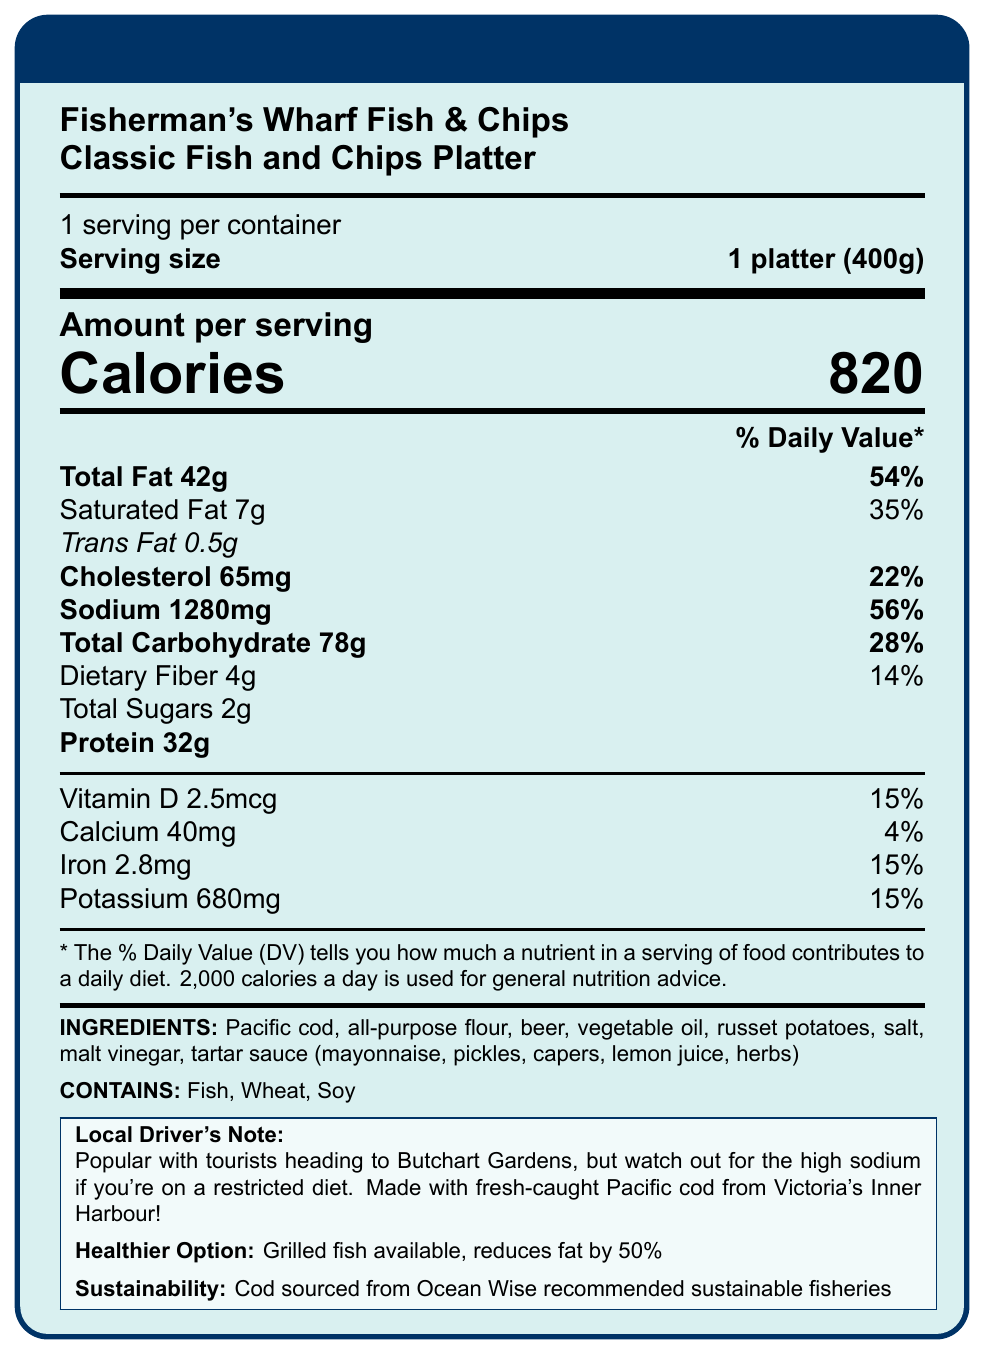what is the total fat content in the Classic Fish and Chips Platter? The document shows that the total fat content for the Classic Fish and Chips Platter is 42g.
Answer: 42g how many calories are in one serving of the Classic Fish and Chips Platter? The document states the calories per serving as 820.
Answer: 820 calories what percentage of the daily value does the sodium content of the platter represent? The document lists the sodium content as 1280mg, which is 56% of the daily value.
Answer: 56% what are the main allergens present in the Classic Fish and Chips Platter? The document clearly mentions that the platter contains Fish, Wheat, and Soy as allergens.
Answer: Fish, Wheat, Soy what is the serving size for this meal? The serving size information is listed as "1 platter (400g)" in the document.
Answer: 1 platter (400g) how much saturated fat is in the Classic Fish and Chips Platter? The document specifies that the saturated fat content is 7g.
Answer: 7g what are the ingredients used in the Classic Fish and Chips Platter? The document has a detailed list of ingredients.
Answer: Pacific cod, all-purpose flour, beer, vegetable oil, russet potatoes, salt, malt vinegar, tartar sauce (mayonnaise, pickles, capers, lemon juice, herbs) which nutrient has the highest daily value percentage in the meal? A. Protein B. Total Fat C. Sodium D. Cholesterol The total fat content has the highest daily value percentage at 54%.
Answer: B how much protein is in the Classic Fish and Chips Platter? A. 20g B. 25g C. 32g D. 40g The protein content is stated as 32g in the document.
Answer: C is the fish in the Classic Fish and Chips Platter sustainably sourced? The document notes that the Pacific cod is sourced from Ocean Wise recommended sustainable fisheries.
Answer: Yes is there any information provided about healthier alternatives? The document mentions a grilled fish option available which reduces the fat content by 50%.
Answer: Yes what is the health advice mentioned by the local taxi driver? The document includes a note stating to watch out for high sodium if on a restricted diet.
Answer: Watch out for the high sodium if you're on a restricted diet what are the total carbohydrates in one serving of the platter? The document indicates that the total carbohydrate content is 78g per serving.
Answer: 78g give a summary of the entire document. The document contains all relevant nutritional information of the Classic Fish and Chips Platter, its allergen content, ingredients, and some extra notes such as sustainability and healthier alternatives.
Answer: The document provides the nutrition facts for the Classic Fish and Chips Platter from Fisherman's Wharf Fish & Chips, including serving size, calories, and detailed nutrient information like fats, carbohydrates, and protein. It also lists the ingredients and allergens. The document notes that the fish is sustainably sourced from Victoria's Inner Harbour and offers a healthier grilled fish option. There is also a note from a local taxi driver about the popularity of the meal among tourists and advice on high sodium content for those on restricted diets. how long does it take to prepare the meal? The document does not provide any details about preparation time.
Answer: Not enough information 